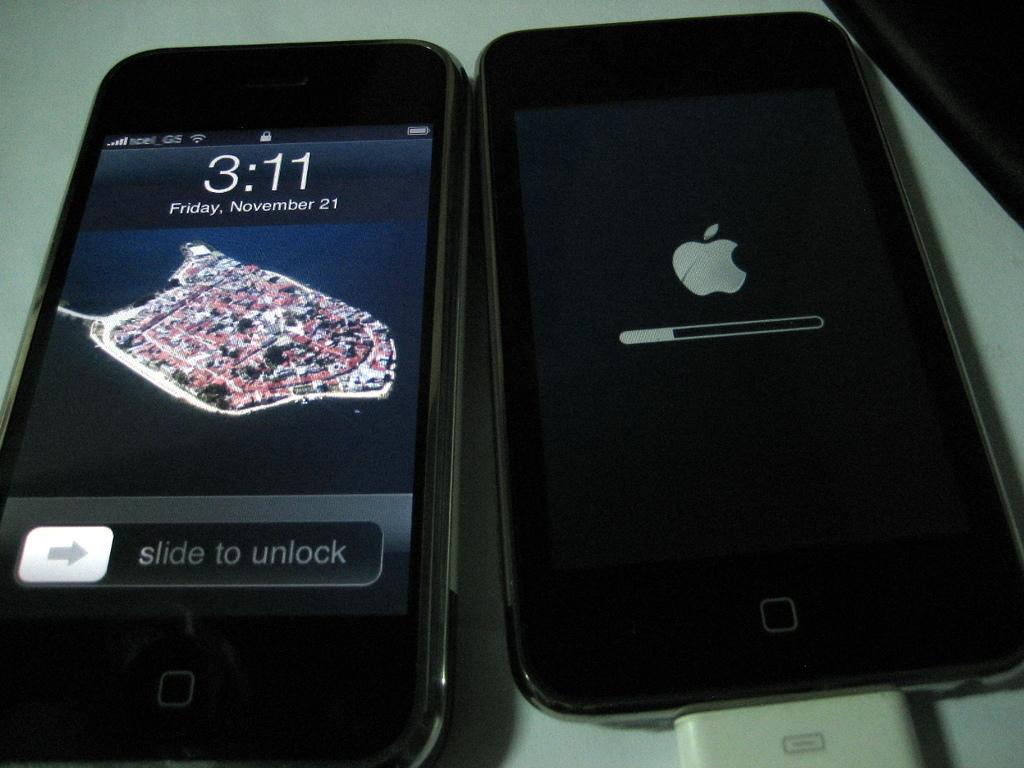<image>
Present a compact description of the photo's key features. Two apple phones side by side with one on the lock screen showing the time as 3:11 on November 21. 